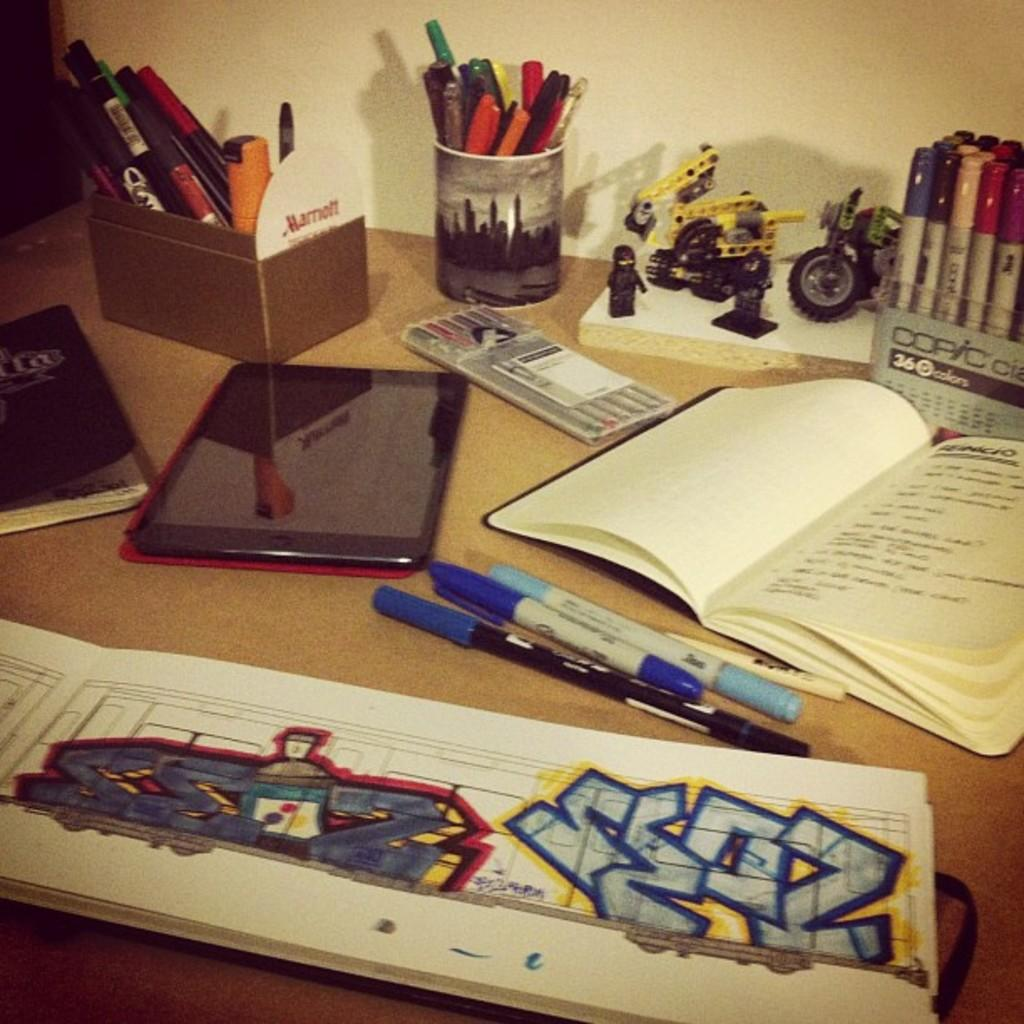What objects related to learning or writing can be seen in the image? There are books and pens in the image. What type of electronic device is present in the image? There is a Tab (likely a tablet device) in the image. What other items can be seen in the image? There is a box and a toy in the image. What can be seen in the background of the image? There is a wall visible in the background of the image. What type of flooring can be seen in the image? There is no information about the flooring in the image, as the focus is on the objects and the wall in the background. Is there a trail visible in the image? There is no trail present in the image; it features objects on a surface and a wall in the background. 